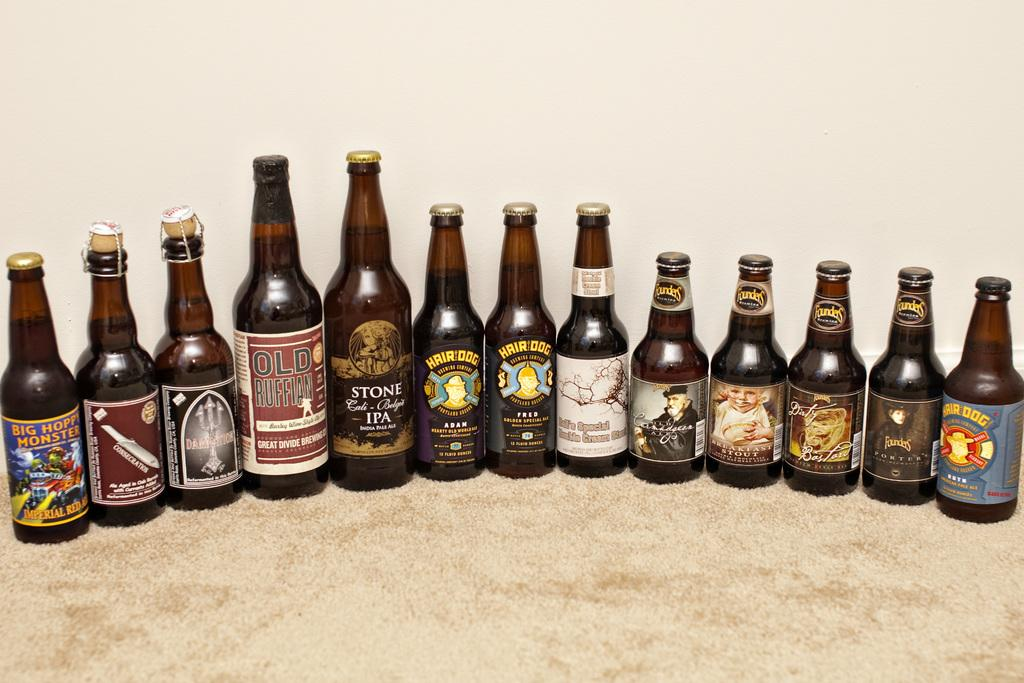<image>
Give a short and clear explanation of the subsequent image. 13 bottles of beer such asstone, hair dog and big hoppy monster 